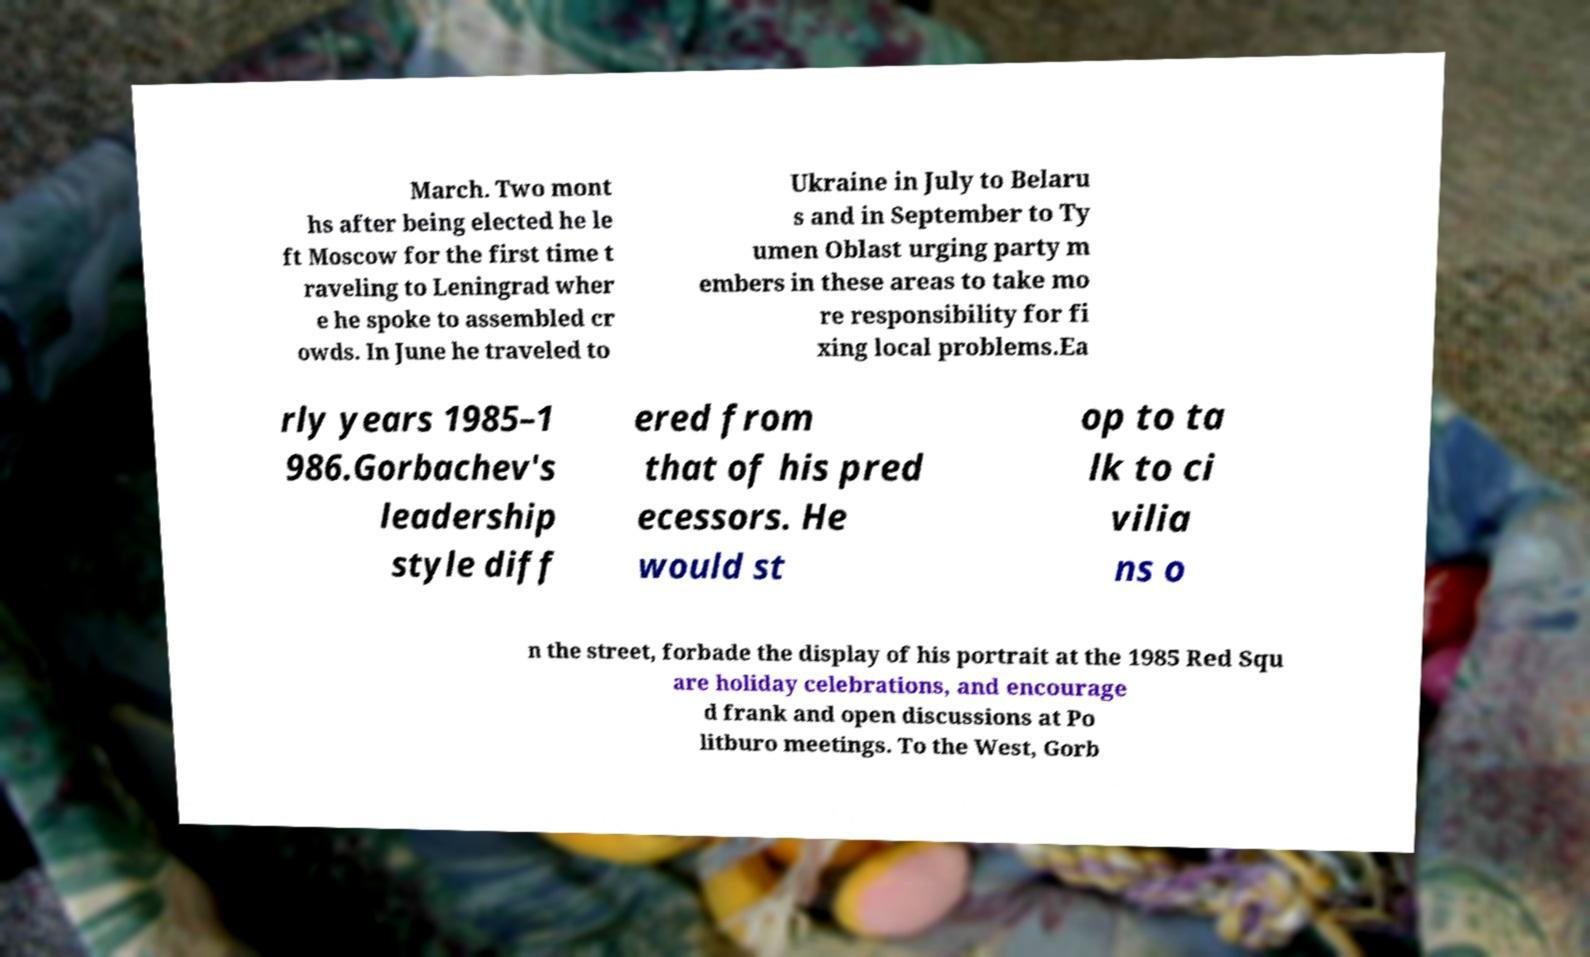Can you read and provide the text displayed in the image?This photo seems to have some interesting text. Can you extract and type it out for me? March. Two mont hs after being elected he le ft Moscow for the first time t raveling to Leningrad wher e he spoke to assembled cr owds. In June he traveled to Ukraine in July to Belaru s and in September to Ty umen Oblast urging party m embers in these areas to take mo re responsibility for fi xing local problems.Ea rly years 1985–1 986.Gorbachev's leadership style diff ered from that of his pred ecessors. He would st op to ta lk to ci vilia ns o n the street, forbade the display of his portrait at the 1985 Red Squ are holiday celebrations, and encourage d frank and open discussions at Po litburo meetings. To the West, Gorb 